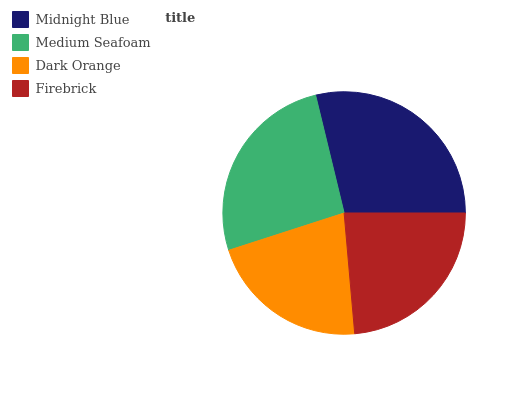Is Dark Orange the minimum?
Answer yes or no. Yes. Is Midnight Blue the maximum?
Answer yes or no. Yes. Is Medium Seafoam the minimum?
Answer yes or no. No. Is Medium Seafoam the maximum?
Answer yes or no. No. Is Midnight Blue greater than Medium Seafoam?
Answer yes or no. Yes. Is Medium Seafoam less than Midnight Blue?
Answer yes or no. Yes. Is Medium Seafoam greater than Midnight Blue?
Answer yes or no. No. Is Midnight Blue less than Medium Seafoam?
Answer yes or no. No. Is Medium Seafoam the high median?
Answer yes or no. Yes. Is Firebrick the low median?
Answer yes or no. Yes. Is Firebrick the high median?
Answer yes or no. No. Is Medium Seafoam the low median?
Answer yes or no. No. 